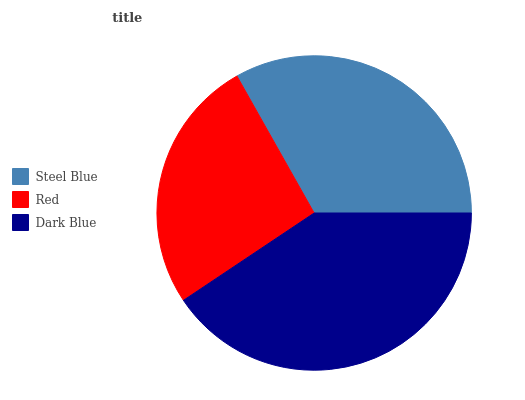Is Red the minimum?
Answer yes or no. Yes. Is Dark Blue the maximum?
Answer yes or no. Yes. Is Dark Blue the minimum?
Answer yes or no. No. Is Red the maximum?
Answer yes or no. No. Is Dark Blue greater than Red?
Answer yes or no. Yes. Is Red less than Dark Blue?
Answer yes or no. Yes. Is Red greater than Dark Blue?
Answer yes or no. No. Is Dark Blue less than Red?
Answer yes or no. No. Is Steel Blue the high median?
Answer yes or no. Yes. Is Steel Blue the low median?
Answer yes or no. Yes. Is Dark Blue the high median?
Answer yes or no. No. Is Red the low median?
Answer yes or no. No. 